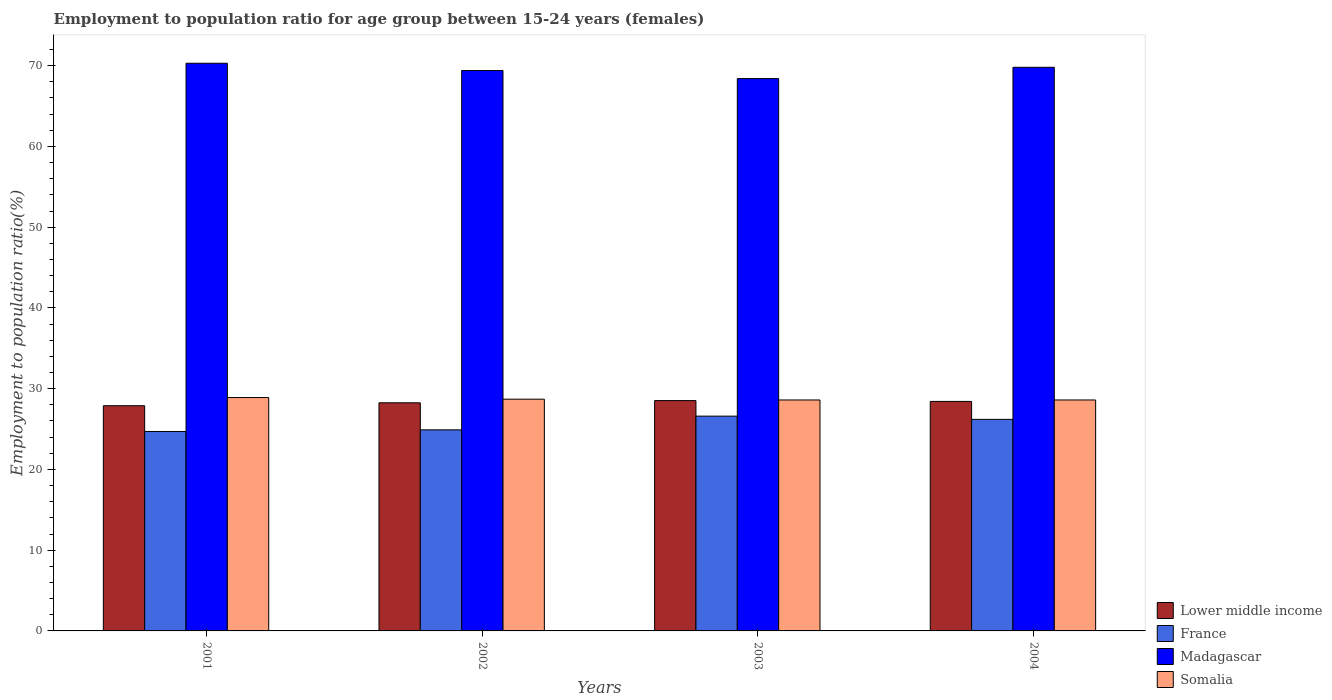How many groups of bars are there?
Offer a very short reply. 4. Are the number of bars per tick equal to the number of legend labels?
Your answer should be compact. Yes. How many bars are there on the 1st tick from the left?
Your response must be concise. 4. How many bars are there on the 3rd tick from the right?
Provide a succinct answer. 4. What is the label of the 2nd group of bars from the left?
Offer a very short reply. 2002. What is the employment to population ratio in Lower middle income in 2003?
Offer a terse response. 28.52. Across all years, what is the maximum employment to population ratio in Somalia?
Offer a very short reply. 28.9. Across all years, what is the minimum employment to population ratio in Lower middle income?
Offer a terse response. 27.89. In which year was the employment to population ratio in Madagascar maximum?
Your answer should be very brief. 2001. What is the total employment to population ratio in Somalia in the graph?
Give a very brief answer. 114.8. What is the difference between the employment to population ratio in Lower middle income in 2001 and that in 2003?
Provide a short and direct response. -0.63. What is the difference between the employment to population ratio in France in 2003 and the employment to population ratio in Madagascar in 2004?
Your answer should be very brief. -43.2. What is the average employment to population ratio in France per year?
Offer a terse response. 25.6. In the year 2004, what is the difference between the employment to population ratio in Lower middle income and employment to population ratio in Somalia?
Provide a succinct answer. -0.18. In how many years, is the employment to population ratio in France greater than 8 %?
Give a very brief answer. 4. What is the ratio of the employment to population ratio in Lower middle income in 2002 to that in 2003?
Keep it short and to the point. 0.99. What is the difference between the highest and the second highest employment to population ratio in Lower middle income?
Your answer should be very brief. 0.1. What is the difference between the highest and the lowest employment to population ratio in Somalia?
Make the answer very short. 0.3. Is it the case that in every year, the sum of the employment to population ratio in Lower middle income and employment to population ratio in Madagascar is greater than the sum of employment to population ratio in France and employment to population ratio in Somalia?
Your response must be concise. Yes. What does the 4th bar from the right in 2003 represents?
Your answer should be very brief. Lower middle income. Does the graph contain any zero values?
Your response must be concise. No. What is the title of the graph?
Offer a terse response. Employment to population ratio for age group between 15-24 years (females). What is the Employment to population ratio(%) of Lower middle income in 2001?
Your answer should be very brief. 27.89. What is the Employment to population ratio(%) in France in 2001?
Ensure brevity in your answer.  24.7. What is the Employment to population ratio(%) in Madagascar in 2001?
Your answer should be very brief. 70.3. What is the Employment to population ratio(%) in Somalia in 2001?
Your answer should be very brief. 28.9. What is the Employment to population ratio(%) in Lower middle income in 2002?
Offer a very short reply. 28.25. What is the Employment to population ratio(%) in France in 2002?
Your response must be concise. 24.9. What is the Employment to population ratio(%) of Madagascar in 2002?
Your response must be concise. 69.4. What is the Employment to population ratio(%) of Somalia in 2002?
Your answer should be compact. 28.7. What is the Employment to population ratio(%) in Lower middle income in 2003?
Your answer should be very brief. 28.52. What is the Employment to population ratio(%) of France in 2003?
Provide a succinct answer. 26.6. What is the Employment to population ratio(%) of Madagascar in 2003?
Offer a very short reply. 68.4. What is the Employment to population ratio(%) of Somalia in 2003?
Make the answer very short. 28.6. What is the Employment to population ratio(%) of Lower middle income in 2004?
Your answer should be very brief. 28.42. What is the Employment to population ratio(%) in France in 2004?
Provide a short and direct response. 26.2. What is the Employment to population ratio(%) of Madagascar in 2004?
Give a very brief answer. 69.8. What is the Employment to population ratio(%) of Somalia in 2004?
Provide a succinct answer. 28.6. Across all years, what is the maximum Employment to population ratio(%) of Lower middle income?
Your answer should be very brief. 28.52. Across all years, what is the maximum Employment to population ratio(%) in France?
Your response must be concise. 26.6. Across all years, what is the maximum Employment to population ratio(%) of Madagascar?
Provide a short and direct response. 70.3. Across all years, what is the maximum Employment to population ratio(%) of Somalia?
Your answer should be compact. 28.9. Across all years, what is the minimum Employment to population ratio(%) of Lower middle income?
Ensure brevity in your answer.  27.89. Across all years, what is the minimum Employment to population ratio(%) in France?
Offer a very short reply. 24.7. Across all years, what is the minimum Employment to population ratio(%) in Madagascar?
Offer a terse response. 68.4. Across all years, what is the minimum Employment to population ratio(%) in Somalia?
Keep it short and to the point. 28.6. What is the total Employment to population ratio(%) of Lower middle income in the graph?
Keep it short and to the point. 113.09. What is the total Employment to population ratio(%) of France in the graph?
Offer a very short reply. 102.4. What is the total Employment to population ratio(%) in Madagascar in the graph?
Offer a very short reply. 277.9. What is the total Employment to population ratio(%) in Somalia in the graph?
Offer a very short reply. 114.8. What is the difference between the Employment to population ratio(%) of Lower middle income in 2001 and that in 2002?
Make the answer very short. -0.36. What is the difference between the Employment to population ratio(%) in France in 2001 and that in 2002?
Offer a very short reply. -0.2. What is the difference between the Employment to population ratio(%) of Lower middle income in 2001 and that in 2003?
Provide a succinct answer. -0.63. What is the difference between the Employment to population ratio(%) of France in 2001 and that in 2003?
Your response must be concise. -1.9. What is the difference between the Employment to population ratio(%) in Madagascar in 2001 and that in 2003?
Your answer should be very brief. 1.9. What is the difference between the Employment to population ratio(%) of Somalia in 2001 and that in 2003?
Ensure brevity in your answer.  0.3. What is the difference between the Employment to population ratio(%) of Lower middle income in 2001 and that in 2004?
Provide a succinct answer. -0.54. What is the difference between the Employment to population ratio(%) in Madagascar in 2001 and that in 2004?
Provide a succinct answer. 0.5. What is the difference between the Employment to population ratio(%) of Lower middle income in 2002 and that in 2003?
Give a very brief answer. -0.27. What is the difference between the Employment to population ratio(%) in Madagascar in 2002 and that in 2003?
Provide a succinct answer. 1. What is the difference between the Employment to population ratio(%) of Lower middle income in 2002 and that in 2004?
Your answer should be very brief. -0.17. What is the difference between the Employment to population ratio(%) of France in 2002 and that in 2004?
Keep it short and to the point. -1.3. What is the difference between the Employment to population ratio(%) in Madagascar in 2002 and that in 2004?
Give a very brief answer. -0.4. What is the difference between the Employment to population ratio(%) in Somalia in 2002 and that in 2004?
Your answer should be compact. 0.1. What is the difference between the Employment to population ratio(%) of Lower middle income in 2003 and that in 2004?
Keep it short and to the point. 0.1. What is the difference between the Employment to population ratio(%) of France in 2003 and that in 2004?
Your answer should be very brief. 0.4. What is the difference between the Employment to population ratio(%) of Madagascar in 2003 and that in 2004?
Keep it short and to the point. -1.4. What is the difference between the Employment to population ratio(%) in Somalia in 2003 and that in 2004?
Give a very brief answer. 0. What is the difference between the Employment to population ratio(%) of Lower middle income in 2001 and the Employment to population ratio(%) of France in 2002?
Keep it short and to the point. 2.99. What is the difference between the Employment to population ratio(%) of Lower middle income in 2001 and the Employment to population ratio(%) of Madagascar in 2002?
Your answer should be very brief. -41.51. What is the difference between the Employment to population ratio(%) in Lower middle income in 2001 and the Employment to population ratio(%) in Somalia in 2002?
Give a very brief answer. -0.81. What is the difference between the Employment to population ratio(%) in France in 2001 and the Employment to population ratio(%) in Madagascar in 2002?
Offer a very short reply. -44.7. What is the difference between the Employment to population ratio(%) of Madagascar in 2001 and the Employment to population ratio(%) of Somalia in 2002?
Give a very brief answer. 41.6. What is the difference between the Employment to population ratio(%) of Lower middle income in 2001 and the Employment to population ratio(%) of France in 2003?
Give a very brief answer. 1.29. What is the difference between the Employment to population ratio(%) of Lower middle income in 2001 and the Employment to population ratio(%) of Madagascar in 2003?
Provide a succinct answer. -40.51. What is the difference between the Employment to population ratio(%) of Lower middle income in 2001 and the Employment to population ratio(%) of Somalia in 2003?
Ensure brevity in your answer.  -0.71. What is the difference between the Employment to population ratio(%) in France in 2001 and the Employment to population ratio(%) in Madagascar in 2003?
Your answer should be compact. -43.7. What is the difference between the Employment to population ratio(%) of France in 2001 and the Employment to population ratio(%) of Somalia in 2003?
Provide a succinct answer. -3.9. What is the difference between the Employment to population ratio(%) in Madagascar in 2001 and the Employment to population ratio(%) in Somalia in 2003?
Offer a very short reply. 41.7. What is the difference between the Employment to population ratio(%) of Lower middle income in 2001 and the Employment to population ratio(%) of France in 2004?
Your response must be concise. 1.69. What is the difference between the Employment to population ratio(%) of Lower middle income in 2001 and the Employment to population ratio(%) of Madagascar in 2004?
Your answer should be very brief. -41.91. What is the difference between the Employment to population ratio(%) of Lower middle income in 2001 and the Employment to population ratio(%) of Somalia in 2004?
Your answer should be compact. -0.71. What is the difference between the Employment to population ratio(%) of France in 2001 and the Employment to population ratio(%) of Madagascar in 2004?
Make the answer very short. -45.1. What is the difference between the Employment to population ratio(%) in France in 2001 and the Employment to population ratio(%) in Somalia in 2004?
Provide a short and direct response. -3.9. What is the difference between the Employment to population ratio(%) of Madagascar in 2001 and the Employment to population ratio(%) of Somalia in 2004?
Provide a short and direct response. 41.7. What is the difference between the Employment to population ratio(%) of Lower middle income in 2002 and the Employment to population ratio(%) of France in 2003?
Offer a terse response. 1.65. What is the difference between the Employment to population ratio(%) of Lower middle income in 2002 and the Employment to population ratio(%) of Madagascar in 2003?
Your answer should be compact. -40.15. What is the difference between the Employment to population ratio(%) in Lower middle income in 2002 and the Employment to population ratio(%) in Somalia in 2003?
Give a very brief answer. -0.35. What is the difference between the Employment to population ratio(%) of France in 2002 and the Employment to population ratio(%) of Madagascar in 2003?
Provide a succinct answer. -43.5. What is the difference between the Employment to population ratio(%) of Madagascar in 2002 and the Employment to population ratio(%) of Somalia in 2003?
Ensure brevity in your answer.  40.8. What is the difference between the Employment to population ratio(%) in Lower middle income in 2002 and the Employment to population ratio(%) in France in 2004?
Provide a short and direct response. 2.05. What is the difference between the Employment to population ratio(%) of Lower middle income in 2002 and the Employment to population ratio(%) of Madagascar in 2004?
Your answer should be compact. -41.55. What is the difference between the Employment to population ratio(%) in Lower middle income in 2002 and the Employment to population ratio(%) in Somalia in 2004?
Give a very brief answer. -0.35. What is the difference between the Employment to population ratio(%) of France in 2002 and the Employment to population ratio(%) of Madagascar in 2004?
Your answer should be very brief. -44.9. What is the difference between the Employment to population ratio(%) in France in 2002 and the Employment to population ratio(%) in Somalia in 2004?
Your answer should be very brief. -3.7. What is the difference between the Employment to population ratio(%) of Madagascar in 2002 and the Employment to population ratio(%) of Somalia in 2004?
Your response must be concise. 40.8. What is the difference between the Employment to population ratio(%) of Lower middle income in 2003 and the Employment to population ratio(%) of France in 2004?
Offer a terse response. 2.32. What is the difference between the Employment to population ratio(%) in Lower middle income in 2003 and the Employment to population ratio(%) in Madagascar in 2004?
Offer a terse response. -41.28. What is the difference between the Employment to population ratio(%) in Lower middle income in 2003 and the Employment to population ratio(%) in Somalia in 2004?
Provide a short and direct response. -0.08. What is the difference between the Employment to population ratio(%) in France in 2003 and the Employment to population ratio(%) in Madagascar in 2004?
Make the answer very short. -43.2. What is the difference between the Employment to population ratio(%) in France in 2003 and the Employment to population ratio(%) in Somalia in 2004?
Ensure brevity in your answer.  -2. What is the difference between the Employment to population ratio(%) of Madagascar in 2003 and the Employment to population ratio(%) of Somalia in 2004?
Offer a terse response. 39.8. What is the average Employment to population ratio(%) in Lower middle income per year?
Ensure brevity in your answer.  28.27. What is the average Employment to population ratio(%) in France per year?
Give a very brief answer. 25.6. What is the average Employment to population ratio(%) of Madagascar per year?
Your answer should be very brief. 69.47. What is the average Employment to population ratio(%) of Somalia per year?
Offer a terse response. 28.7. In the year 2001, what is the difference between the Employment to population ratio(%) in Lower middle income and Employment to population ratio(%) in France?
Provide a succinct answer. 3.19. In the year 2001, what is the difference between the Employment to population ratio(%) in Lower middle income and Employment to population ratio(%) in Madagascar?
Provide a succinct answer. -42.41. In the year 2001, what is the difference between the Employment to population ratio(%) of Lower middle income and Employment to population ratio(%) of Somalia?
Your answer should be very brief. -1.01. In the year 2001, what is the difference between the Employment to population ratio(%) in France and Employment to population ratio(%) in Madagascar?
Offer a very short reply. -45.6. In the year 2001, what is the difference between the Employment to population ratio(%) of Madagascar and Employment to population ratio(%) of Somalia?
Provide a succinct answer. 41.4. In the year 2002, what is the difference between the Employment to population ratio(%) of Lower middle income and Employment to population ratio(%) of France?
Your response must be concise. 3.35. In the year 2002, what is the difference between the Employment to population ratio(%) in Lower middle income and Employment to population ratio(%) in Madagascar?
Provide a short and direct response. -41.15. In the year 2002, what is the difference between the Employment to population ratio(%) in Lower middle income and Employment to population ratio(%) in Somalia?
Keep it short and to the point. -0.45. In the year 2002, what is the difference between the Employment to population ratio(%) of France and Employment to population ratio(%) of Madagascar?
Make the answer very short. -44.5. In the year 2002, what is the difference between the Employment to population ratio(%) in France and Employment to population ratio(%) in Somalia?
Your answer should be compact. -3.8. In the year 2002, what is the difference between the Employment to population ratio(%) of Madagascar and Employment to population ratio(%) of Somalia?
Ensure brevity in your answer.  40.7. In the year 2003, what is the difference between the Employment to population ratio(%) of Lower middle income and Employment to population ratio(%) of France?
Offer a terse response. 1.92. In the year 2003, what is the difference between the Employment to population ratio(%) of Lower middle income and Employment to population ratio(%) of Madagascar?
Make the answer very short. -39.88. In the year 2003, what is the difference between the Employment to population ratio(%) of Lower middle income and Employment to population ratio(%) of Somalia?
Offer a very short reply. -0.08. In the year 2003, what is the difference between the Employment to population ratio(%) of France and Employment to population ratio(%) of Madagascar?
Provide a succinct answer. -41.8. In the year 2003, what is the difference between the Employment to population ratio(%) in Madagascar and Employment to population ratio(%) in Somalia?
Provide a succinct answer. 39.8. In the year 2004, what is the difference between the Employment to population ratio(%) of Lower middle income and Employment to population ratio(%) of France?
Offer a terse response. 2.22. In the year 2004, what is the difference between the Employment to population ratio(%) of Lower middle income and Employment to population ratio(%) of Madagascar?
Give a very brief answer. -41.38. In the year 2004, what is the difference between the Employment to population ratio(%) of Lower middle income and Employment to population ratio(%) of Somalia?
Offer a terse response. -0.18. In the year 2004, what is the difference between the Employment to population ratio(%) in France and Employment to population ratio(%) in Madagascar?
Your answer should be compact. -43.6. In the year 2004, what is the difference between the Employment to population ratio(%) in Madagascar and Employment to population ratio(%) in Somalia?
Offer a very short reply. 41.2. What is the ratio of the Employment to population ratio(%) of Lower middle income in 2001 to that in 2002?
Your response must be concise. 0.99. What is the ratio of the Employment to population ratio(%) of Somalia in 2001 to that in 2002?
Make the answer very short. 1.01. What is the ratio of the Employment to population ratio(%) of Lower middle income in 2001 to that in 2003?
Keep it short and to the point. 0.98. What is the ratio of the Employment to population ratio(%) of Madagascar in 2001 to that in 2003?
Offer a very short reply. 1.03. What is the ratio of the Employment to population ratio(%) of Somalia in 2001 to that in 2003?
Keep it short and to the point. 1.01. What is the ratio of the Employment to population ratio(%) in Lower middle income in 2001 to that in 2004?
Offer a terse response. 0.98. What is the ratio of the Employment to population ratio(%) of France in 2001 to that in 2004?
Your answer should be very brief. 0.94. What is the ratio of the Employment to population ratio(%) of Somalia in 2001 to that in 2004?
Make the answer very short. 1.01. What is the ratio of the Employment to population ratio(%) of Lower middle income in 2002 to that in 2003?
Provide a succinct answer. 0.99. What is the ratio of the Employment to population ratio(%) in France in 2002 to that in 2003?
Make the answer very short. 0.94. What is the ratio of the Employment to population ratio(%) of Madagascar in 2002 to that in 2003?
Provide a succinct answer. 1.01. What is the ratio of the Employment to population ratio(%) in Somalia in 2002 to that in 2003?
Your answer should be compact. 1. What is the ratio of the Employment to population ratio(%) of Lower middle income in 2002 to that in 2004?
Your response must be concise. 0.99. What is the ratio of the Employment to population ratio(%) of France in 2002 to that in 2004?
Offer a terse response. 0.95. What is the ratio of the Employment to population ratio(%) of Lower middle income in 2003 to that in 2004?
Ensure brevity in your answer.  1. What is the ratio of the Employment to population ratio(%) of France in 2003 to that in 2004?
Give a very brief answer. 1.02. What is the ratio of the Employment to population ratio(%) in Madagascar in 2003 to that in 2004?
Provide a succinct answer. 0.98. What is the difference between the highest and the second highest Employment to population ratio(%) of Lower middle income?
Offer a very short reply. 0.1. What is the difference between the highest and the second highest Employment to population ratio(%) in Somalia?
Offer a very short reply. 0.2. What is the difference between the highest and the lowest Employment to population ratio(%) in Lower middle income?
Provide a short and direct response. 0.63. What is the difference between the highest and the lowest Employment to population ratio(%) in France?
Ensure brevity in your answer.  1.9. What is the difference between the highest and the lowest Employment to population ratio(%) of Madagascar?
Ensure brevity in your answer.  1.9. What is the difference between the highest and the lowest Employment to population ratio(%) of Somalia?
Give a very brief answer. 0.3. 